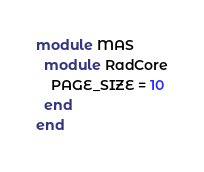Convert code to text. <code><loc_0><loc_0><loc_500><loc_500><_Ruby_>
module MAS
  module RadCore
    PAGE_SIZE = 10
  end
end
</code> 